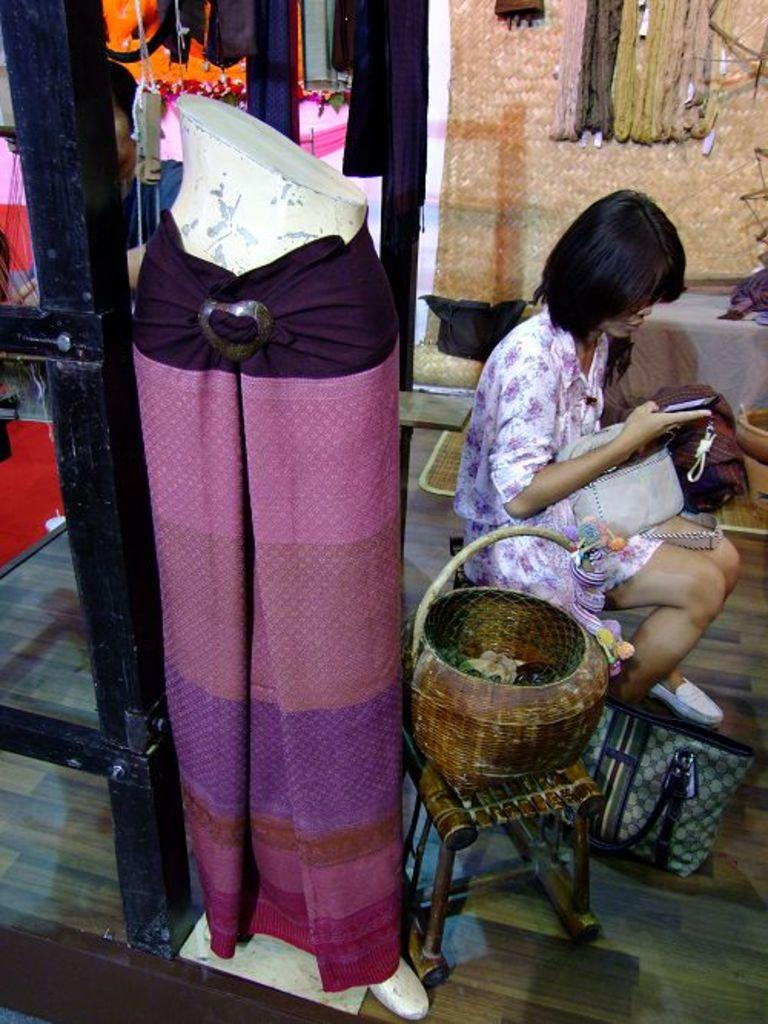Who is present in the image? There is a woman in the image. What is the woman doing in the image? The woman is seated on a chair in the image. What is the woman holding in her hand? The woman is holding a mobile in her hand. What other objects can be seen in the image? There is a basket and a mannequin in the image. What credit score does the mannequin have in the image? There is no mention of credit scores or financial information in the image, as it features a woman seated on a chair, holding a mobile, and a mannequin and basket in the background. 